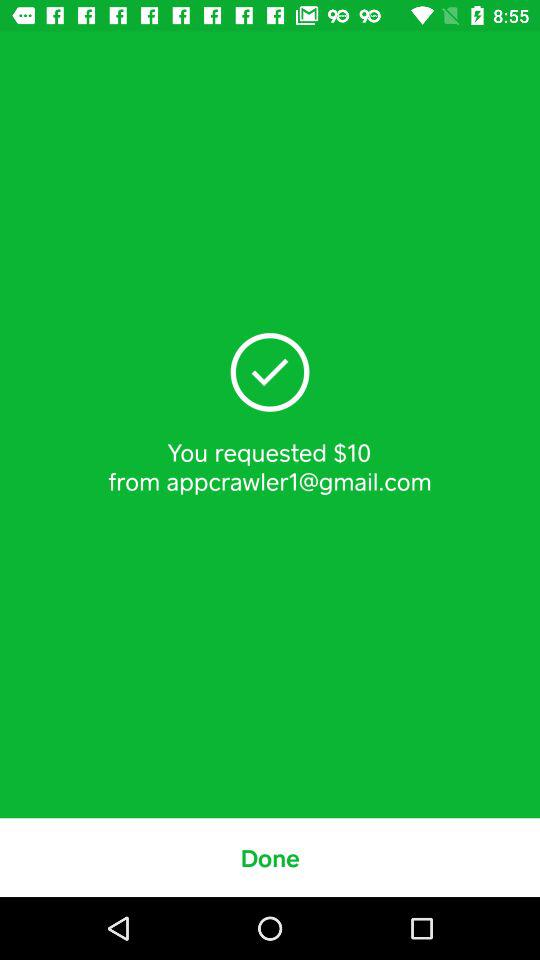What is the email address? The email address is appcrawler1@gmail.com. 